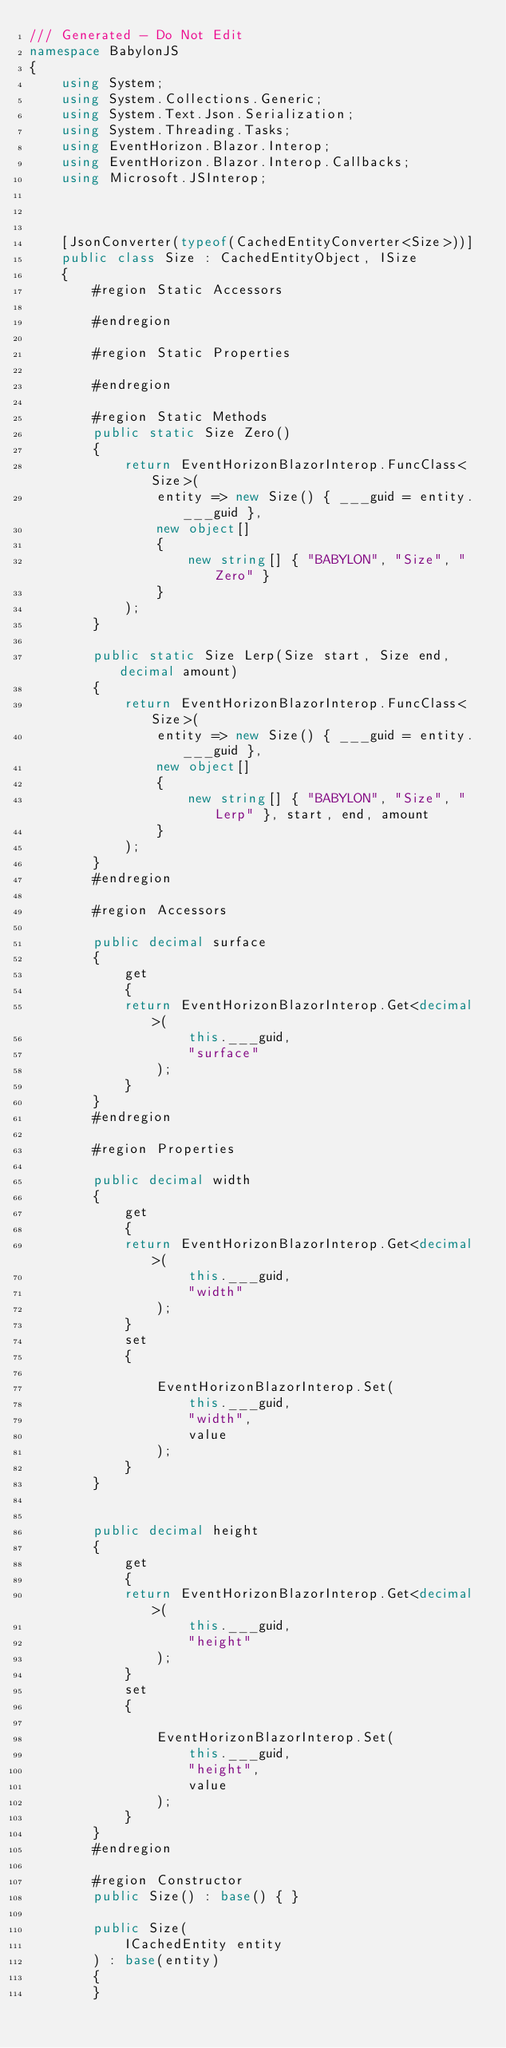Convert code to text. <code><loc_0><loc_0><loc_500><loc_500><_C#_>/// Generated - Do Not Edit
namespace BabylonJS
{
    using System;
    using System.Collections.Generic;
    using System.Text.Json.Serialization;
    using System.Threading.Tasks;
    using EventHorizon.Blazor.Interop;
    using EventHorizon.Blazor.Interop.Callbacks;
    using Microsoft.JSInterop;

    
    
    [JsonConverter(typeof(CachedEntityConverter<Size>))]
    public class Size : CachedEntityObject, ISize
    {
        #region Static Accessors

        #endregion

        #region Static Properties

        #endregion

        #region Static Methods
        public static Size Zero()
        {
            return EventHorizonBlazorInterop.FuncClass<Size>(
                entity => new Size() { ___guid = entity.___guid },
                new object[]
                {
                    new string[] { "BABYLON", "Size", "Zero" }
                }
            );
        }

        public static Size Lerp(Size start, Size end, decimal amount)
        {
            return EventHorizonBlazorInterop.FuncClass<Size>(
                entity => new Size() { ___guid = entity.___guid },
                new object[]
                {
                    new string[] { "BABYLON", "Size", "Lerp" }, start, end, amount
                }
            );
        }
        #endregion

        #region Accessors
        
        public decimal surface
        {
            get
            {
            return EventHorizonBlazorInterop.Get<decimal>(
                    this.___guid,
                    "surface"
                );
            }
        }
        #endregion

        #region Properties
        
        public decimal width
        {
            get
            {
            return EventHorizonBlazorInterop.Get<decimal>(
                    this.___guid,
                    "width"
                );
            }
            set
            {

                EventHorizonBlazorInterop.Set(
                    this.___guid,
                    "width",
                    value
                );
            }
        }

        
        public decimal height
        {
            get
            {
            return EventHorizonBlazorInterop.Get<decimal>(
                    this.___guid,
                    "height"
                );
            }
            set
            {

                EventHorizonBlazorInterop.Set(
                    this.___guid,
                    "height",
                    value
                );
            }
        }
        #endregion
        
        #region Constructor
        public Size() : base() { }

        public Size(
            ICachedEntity entity
        ) : base(entity)
        {
        }
</code> 